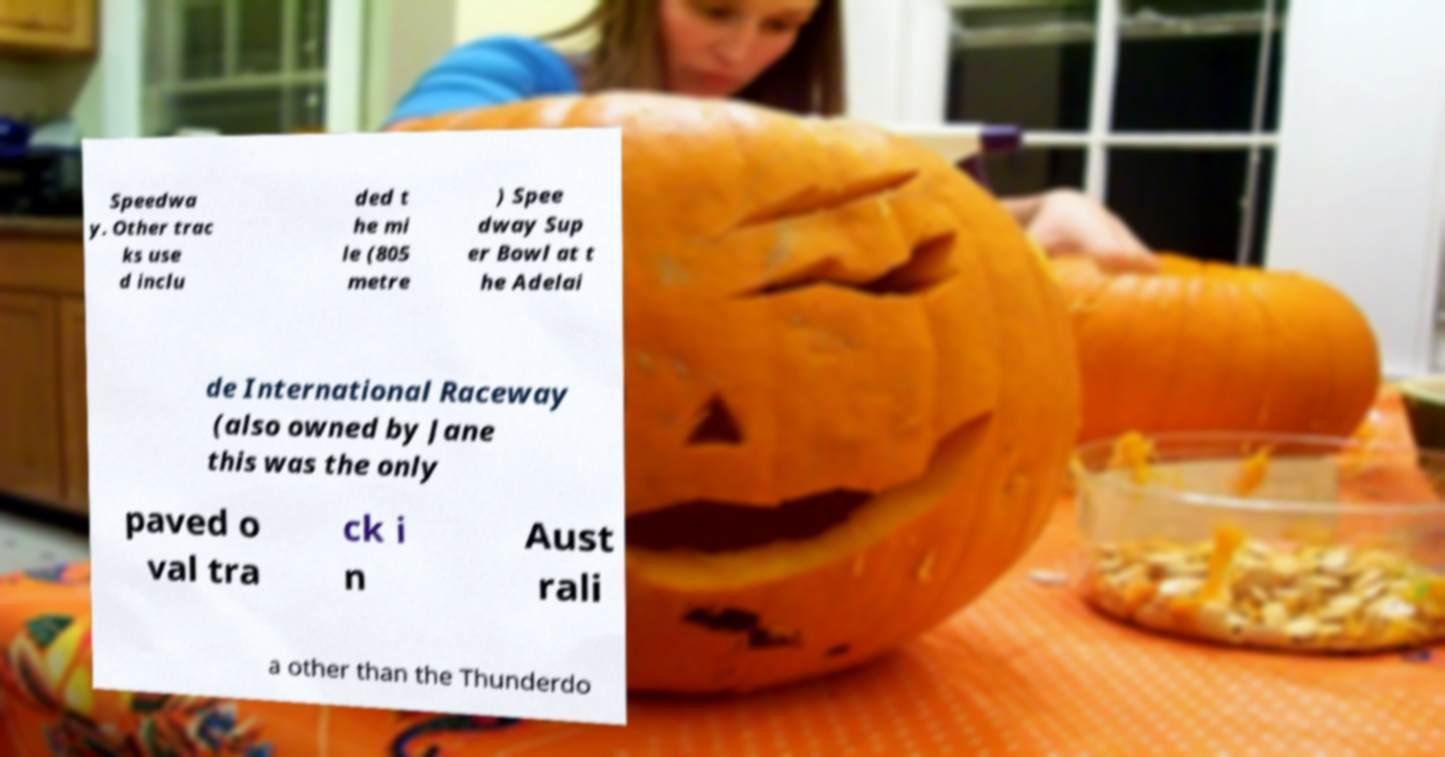Could you extract and type out the text from this image? Speedwa y. Other trac ks use d inclu ded t he mi le (805 metre ) Spee dway Sup er Bowl at t he Adelai de International Raceway (also owned by Jane this was the only paved o val tra ck i n Aust rali a other than the Thunderdo 